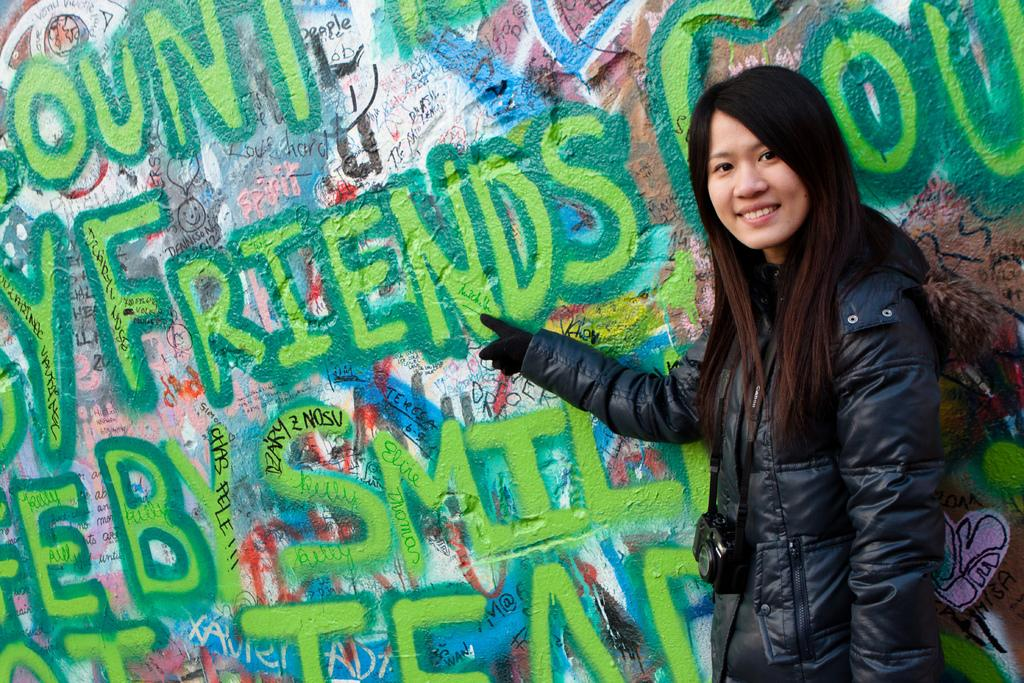What is the person in the image doing? The person is standing in the image and holding a camera. What is the person wearing in the image? The person is wearing a jacket in the image. What can be seen in the background of the image? There is a wall visible in the image, and many names are written on the wall. What type of sand can be seen on the floor in the image? There is no sand present on the floor in the image. Is there a lock attached to the wall in the image? There is no lock visible on the wall in the image. 